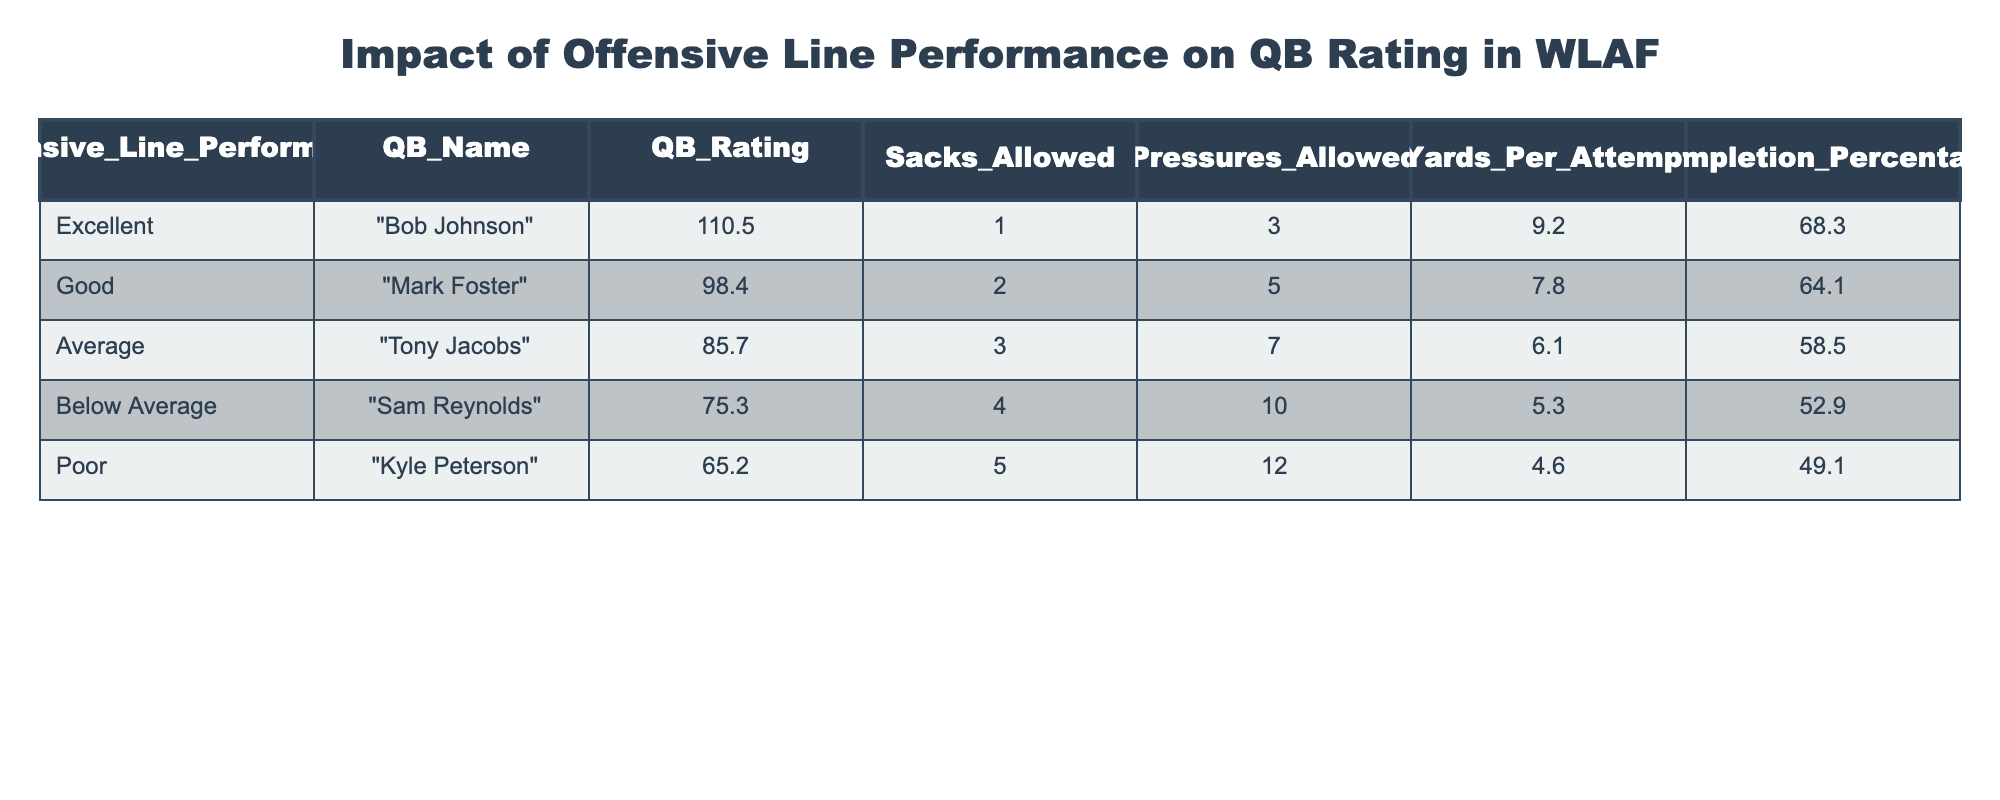What is the QB rating for Bob Johnson? According to the table, Bob Johnson is listed under the "Excellent" category of Offensive Line Performance with a corresponding QB Rating of 110.5.
Answer: 110.5 How many sacks were allowed for the quarterback with the highest rating? The quarterback with the highest rating is Bob Johnson, who had 1 sack allowed according to the data presented in the table.
Answer: 1 Which quarterback had the highest completion percentage? Referring to the table, Bob Johnson has the highest completion percentage at 68.3%. No other quarterback exceeds this value, confirming he has the highest percentage.
Answer: 68.3 True or false: Kyle Peterson had a lower QB rating than Sam Reynolds. Kyle Peterson’s QB rating is 65.2, while Sam Reynolds’ QB rating is 75.3. Since 65.2 is less than 75.3, the statement is true.
Answer: True What is the average QB rating for quarterbacks whose performance is below average or poor? The quarterbacks categorized as "Below Average" and "Poor" are Sam Reynolds (75.3) and Kyle Peterson (65.2). We sum their ratings: 75.3 + 65.2 = 140.5 and then divide by 2, which results in an average of 70.25.
Answer: 70.25 How many total pressures were allowed by quarterbacks with excellent and good offensive line performance? The quarterbacks categorized as "Excellent" (Bob Johnson) and "Good" (Mark Foster) allowed a total of 3 and 5 pressures, respectively. Adding these gives 3 + 5 = 8 total pressures allowed.
Answer: 8 Which quarterbacks had more than 4 sacks allowed? Referring to the table, Sam Reynolds (4 sacks) and Kyle Peterson (5 sacks) had more than 4 sacks allowed. Therefore, both are included in the answer.
Answer: Sam Reynolds and Kyle Peterson What is the difference in completion percentage between the highest and lowest performing quarterbacks? The highest completion percentage is that of Bob Johnson at 68.3% and the lowest is Kyle Peterson at 49.1%. The difference is calculated as 68.3 - 49.1 = 19.2, reflecting the gap in performance.
Answer: 19.2 How many quarterbacks have a QB rating above 90? The quarterbacks with a QB rating above 90 are Bob Johnson (110.5) and Mark Foster (98.4), leading to a total of 2 quarterbacks in this category.
Answer: 2 